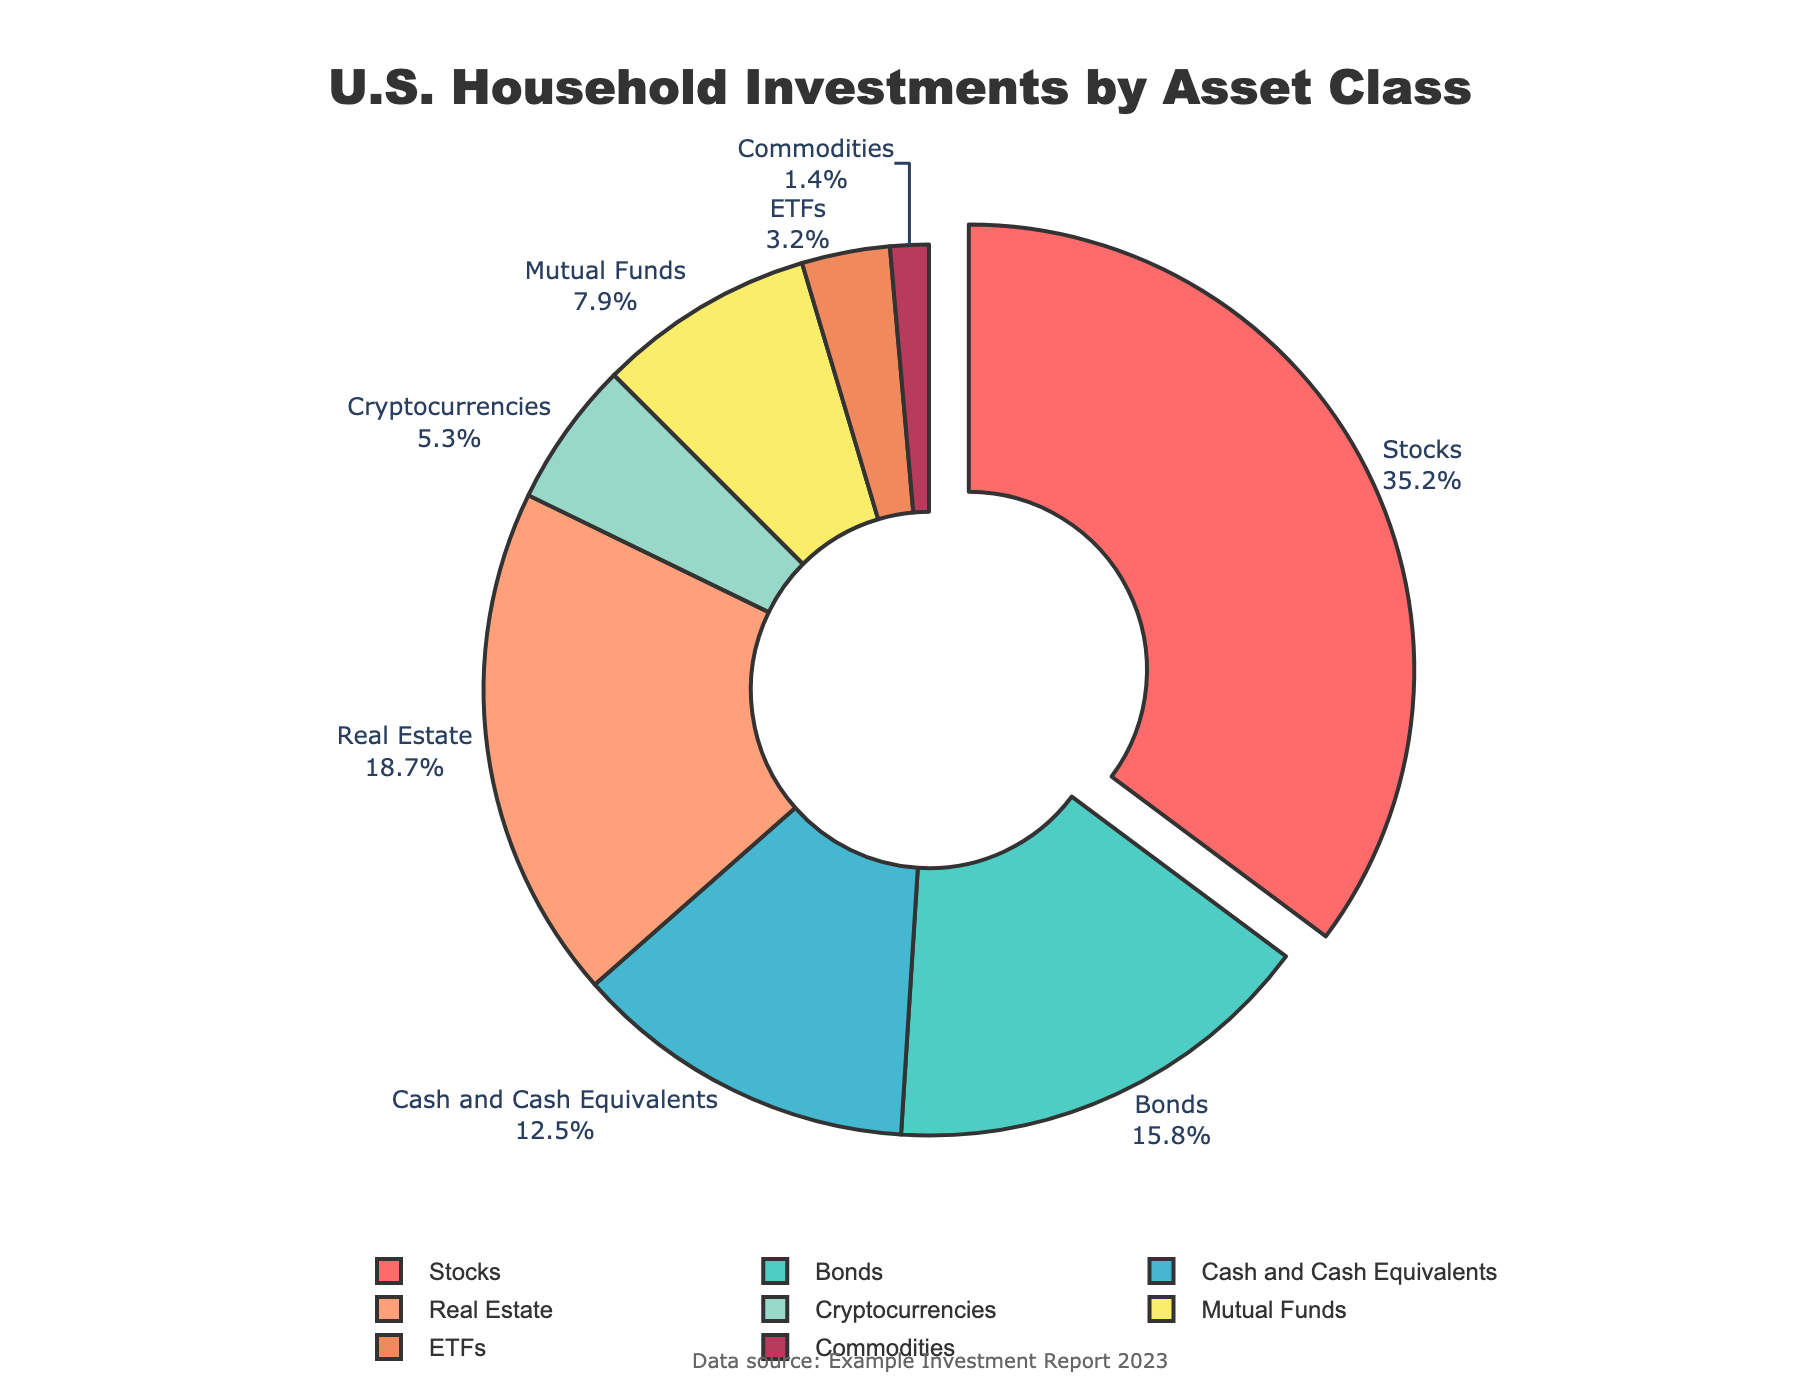What asset class holds the largest percentage of U.S. household investments? The pie chart visually emphasizes that the largest segment, which is slightly pulled out for prominence, is labeled "Stocks" with a percentage of 35.2%.
Answer: Stocks What is the combined percentage of investments in Bonds and Mutual Funds? To find the combined percentage, add the percentage of Bonds (15.8%) to that of Mutual Funds (7.9%): 15.8 + 7.9.
Answer: 23.7% Which is greater, the percentage of investments in Cryptocurrencies or ETFs? Compare the segments labeled "Cryptocurrencies" (5.3%) and "ETFs" (3.2%). Since 5.3% is greater than 3.2%, Cryptocurrencies have a greater percentage.
Answer: Cryptocurrencies By how many percentage points does the investment in Real Estate exceed that in Cash and Cash Equivalents? Subtract the percentage of Cash and Cash Equivalents (12.5%) from Real Estate (18.7%): 18.7 - 12.5.
Answer: 6.2% Which asset classes are represented with more than 10% but less than 20% of the total investments? Identify segments within this range: "Bonds" (15.8%) and "Real Estate" (18.7%) both fall between 10% and 20%.
Answer: Bonds, Real Estate What is the total percentage of investments in Stocks, Bonds, and Cash and Cash Equivalents combined? Add the percentages: Stocks (35.2%), Bonds (15.8%), and Cash and Cash Equivalents (12.5%): 35.2 + 15.8 + 12.5.
Answer: 63.5% Which asset class has the smallest percentage of U.S. household investments? The smallest segment in the pie chart is labeled "Commodities" with a percentage of 1.4%.
Answer: Commodities What is the difference in percentage points between the investments in ETFs and Commodities? Subtract the percentage of Commodities (1.4%) from ETFs (3.2%): 3.2 - 1.4.
Answer: 1.8% How much do the 'Stocks' and 'Real Estate' segments together contribute to the total percentage? Add the percentages: Stocks (35.2%) and Real Estate (18.7%): 35.2 + 18.7.
Answer: 53.9% If you combine the investments in Cryptocurrencies, Mutual Funds, and ETFs, do they exceed the percentage in Real Estate? Add the percentages of Cryptocurrencies (5.3%), Mutual Funds (7.9%), and ETFs (3.2%): 5.3 + 7.9 + 3.2 = 16.4%. Compare this to Real Estate (18.7%). Since 16.4% is less than 18.7%, the combination does not exceed Real Estate.
Answer: No 